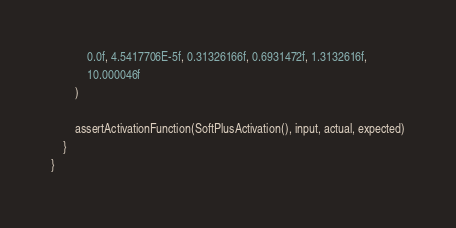Convert code to text. <code><loc_0><loc_0><loc_500><loc_500><_Kotlin_>            0.0f, 4.5417706E-5f, 0.31326166f, 0.6931472f, 1.3132616f,
            10.000046f
        )

        assertActivationFunction(SoftPlusActivation(), input, actual, expected)
    }
}</code> 